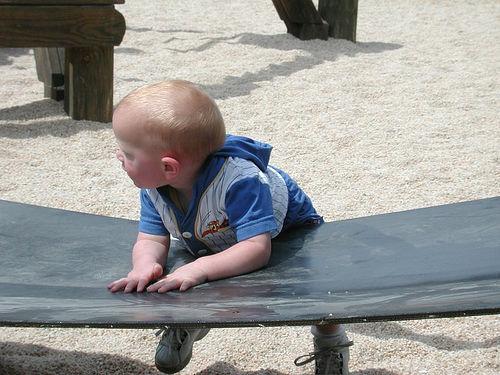How are the shoe strings?
Answer briefly. Tied. Who is watching the baby?
Concise answer only. No one. Which direction is the child looking?
Answer briefly. Left. 